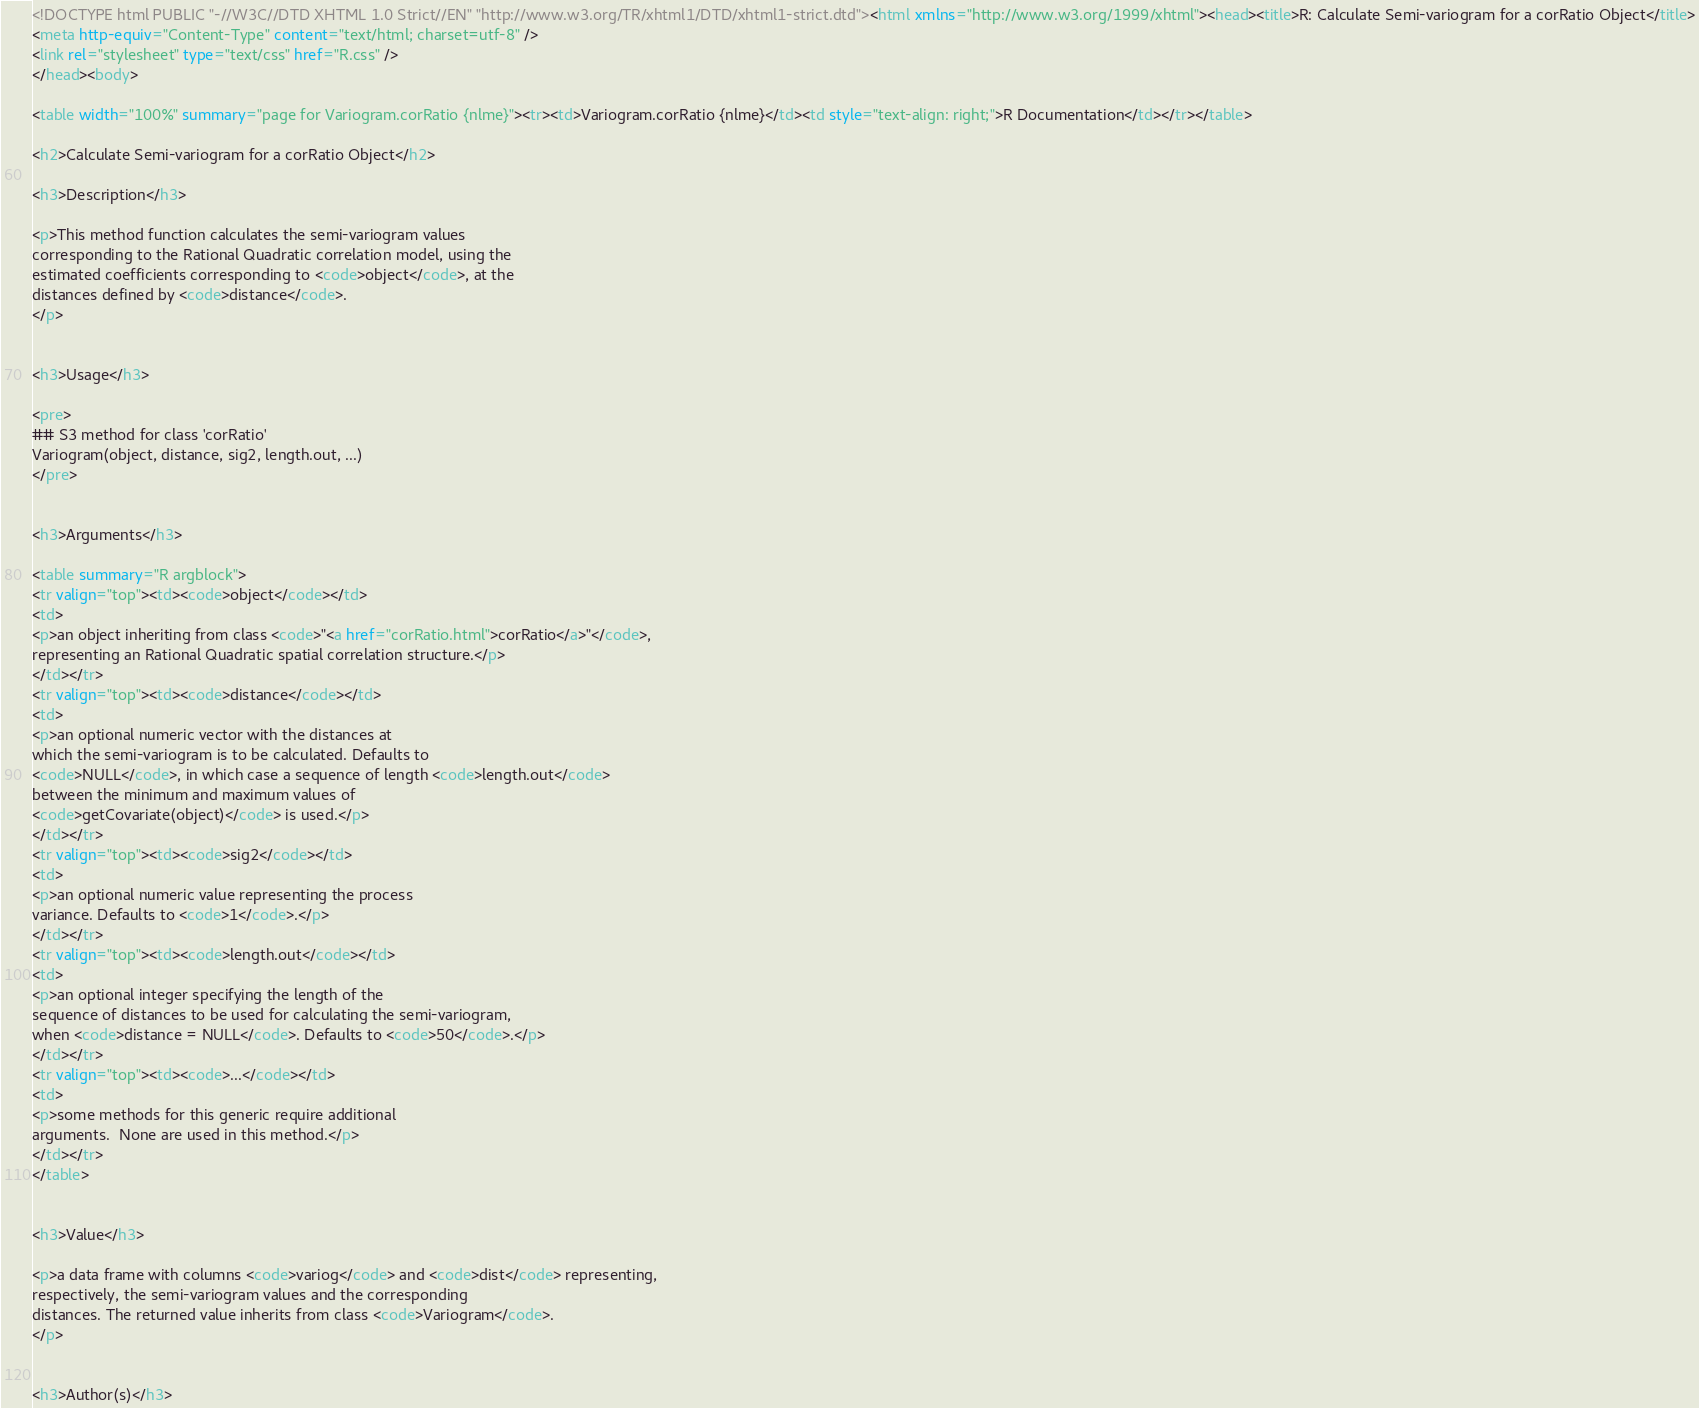<code> <loc_0><loc_0><loc_500><loc_500><_HTML_><!DOCTYPE html PUBLIC "-//W3C//DTD XHTML 1.0 Strict//EN" "http://www.w3.org/TR/xhtml1/DTD/xhtml1-strict.dtd"><html xmlns="http://www.w3.org/1999/xhtml"><head><title>R: Calculate Semi-variogram for a corRatio Object</title>
<meta http-equiv="Content-Type" content="text/html; charset=utf-8" />
<link rel="stylesheet" type="text/css" href="R.css" />
</head><body>

<table width="100%" summary="page for Variogram.corRatio {nlme}"><tr><td>Variogram.corRatio {nlme}</td><td style="text-align: right;">R Documentation</td></tr></table>

<h2>Calculate Semi-variogram for a corRatio Object</h2>

<h3>Description</h3>

<p>This method function calculates the semi-variogram values
corresponding to the Rational Quadratic correlation model, using the
estimated coefficients corresponding to <code>object</code>, at the
distances defined by <code>distance</code>.
</p>


<h3>Usage</h3>

<pre>
## S3 method for class 'corRatio'
Variogram(object, distance, sig2, length.out, ...)
</pre>


<h3>Arguments</h3>

<table summary="R argblock">
<tr valign="top"><td><code>object</code></td>
<td>
<p>an object inheriting from class <code>"<a href="corRatio.html">corRatio</a>"</code>,
representing an Rational Quadratic spatial correlation structure.</p>
</td></tr>
<tr valign="top"><td><code>distance</code></td>
<td>
<p>an optional numeric vector with the distances at
which the semi-variogram is to be calculated. Defaults to
<code>NULL</code>, in which case a sequence of length <code>length.out</code>
between the minimum and maximum values of
<code>getCovariate(object)</code> is used.</p>
</td></tr>
<tr valign="top"><td><code>sig2</code></td>
<td>
<p>an optional numeric value representing the process
variance. Defaults to <code>1</code>.</p>
</td></tr>
<tr valign="top"><td><code>length.out</code></td>
<td>
<p>an optional integer specifying the length of the
sequence of distances to be used for calculating the semi-variogram,
when <code>distance = NULL</code>. Defaults to <code>50</code>.</p>
</td></tr>
<tr valign="top"><td><code>...</code></td>
<td>
<p>some methods for this generic require additional
arguments.  None are used in this method.</p>
</td></tr> 
</table>


<h3>Value</h3>

<p>a data frame with columns <code>variog</code> and <code>dist</code> representing,
respectively, the semi-variogram values and the corresponding
distances. The returned value inherits from class <code>Variogram</code>. 
</p>


<h3>Author(s)</h3>
</code> 